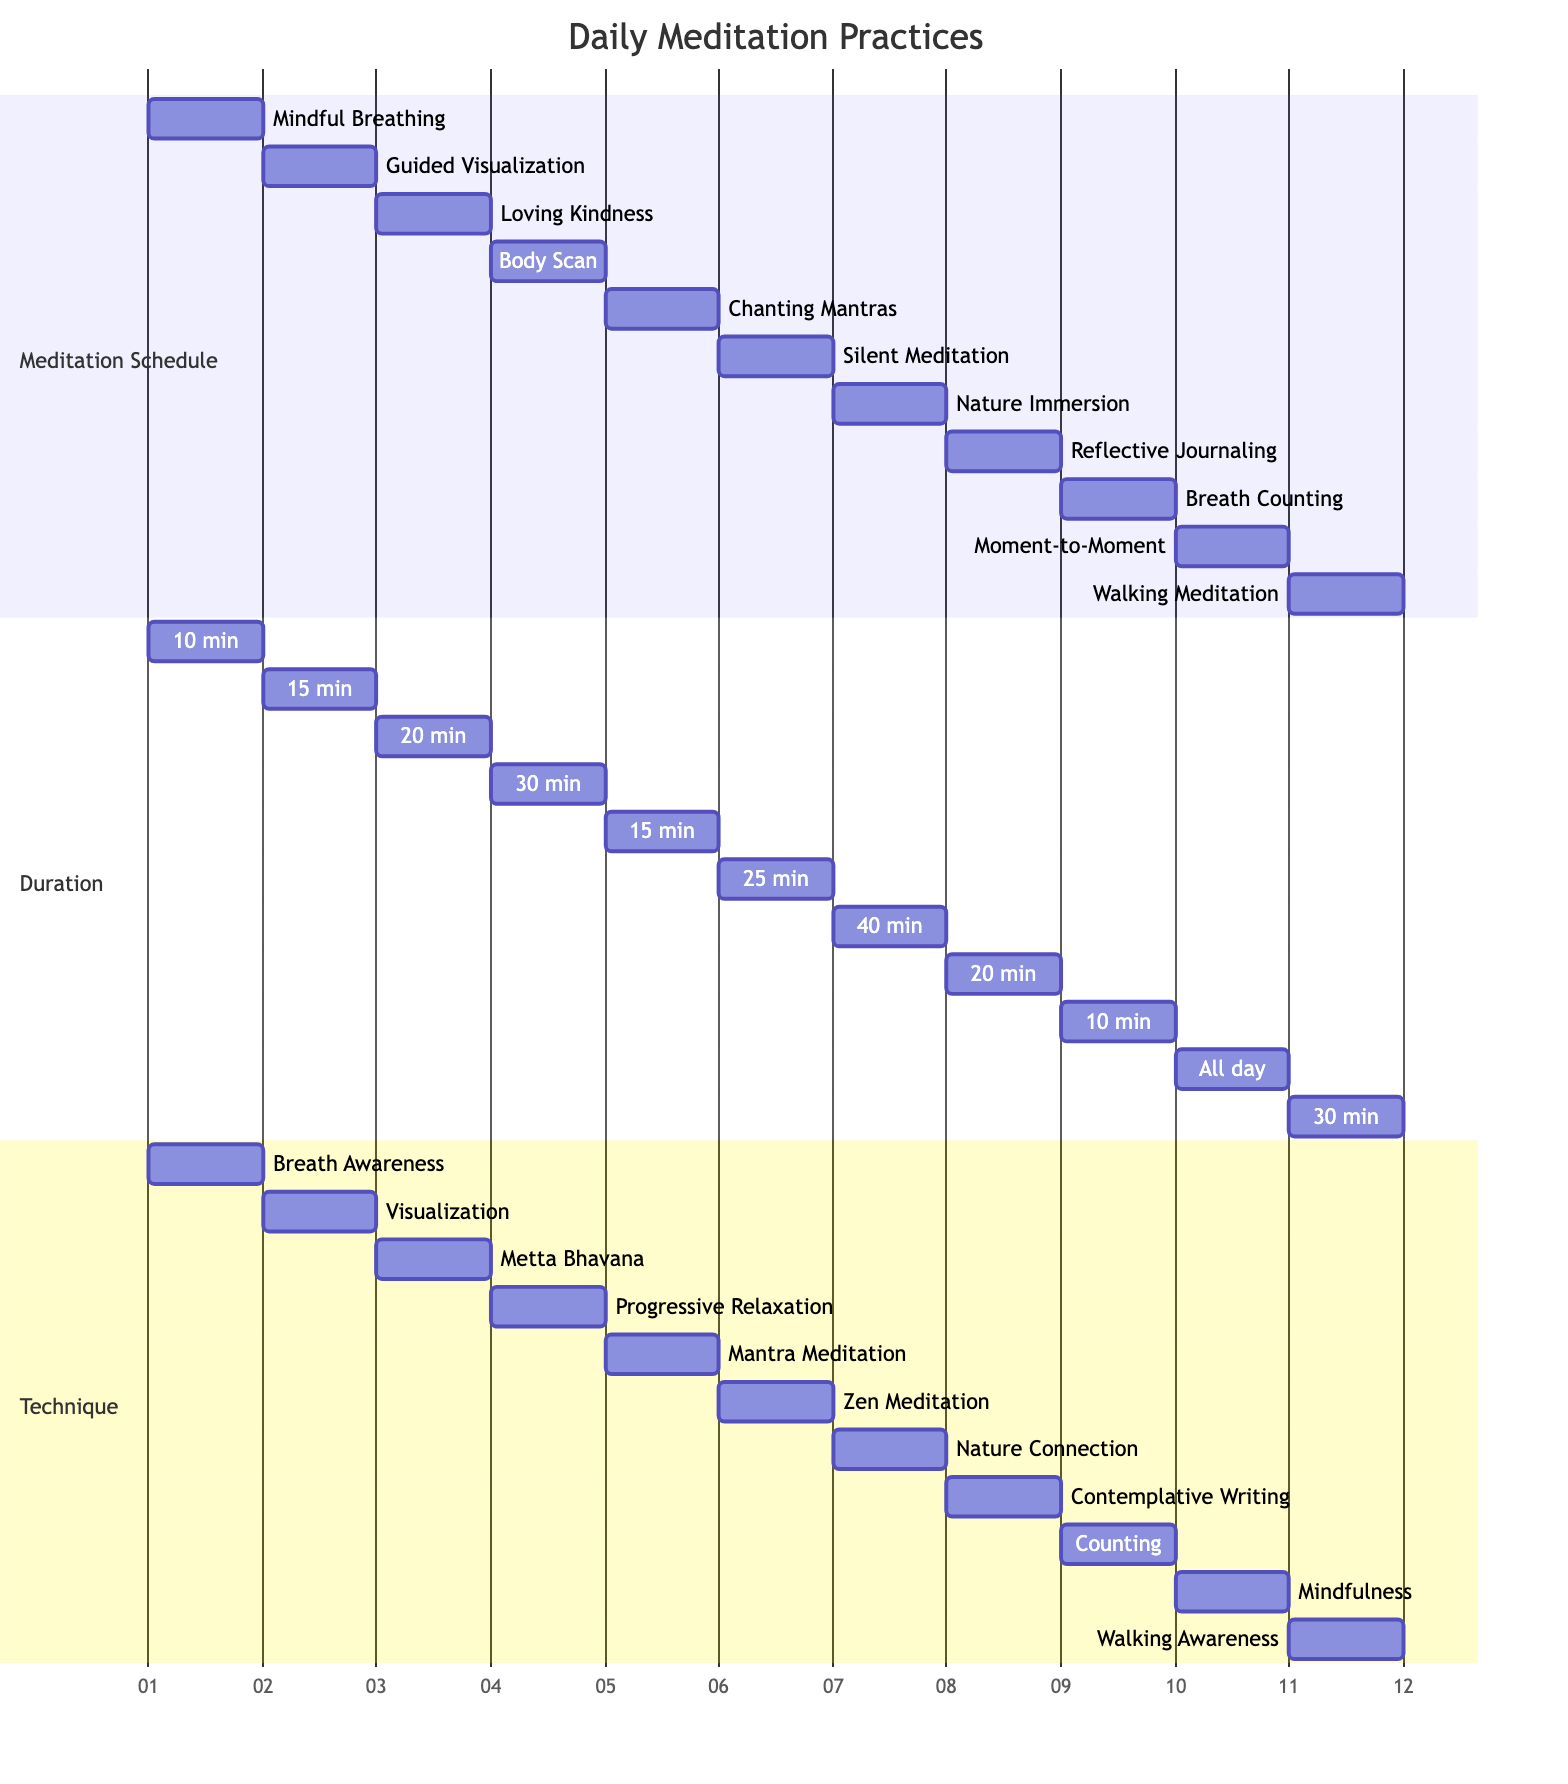What meditation technique is practiced on Day 1? The diagram indicates that on Day 1, the meditation practice is "Mindful Breathing," which focuses on present moment awareness through breath awareness.
Answer: Mindful Breathing How long is the Silent Meditation session? According to the diagram, the duration for Silent Meditation is specified as 25 minutes, which is noted under the duration section for Day 6.
Answer: 25 minutes On which day is Nature Immersion scheduled? By referring to the diagram, Nature Immersion can be found listed on Day 7, thus indicating when this specific practice is scheduled.
Answer: Day 7 What is the total number of meditation practices shown in the diagram? To find the total number of practices, count the number of entries under the Meditation Schedule section, which totals to 11 different meditation practices displayed in the diagram.
Answer: 11 Which meditation practice requires the longest duration? Upon examining the durations in the Duration section, the practice that takes the longest time is "Nature Immersion," which is set for 40 minutes, as listed on Day 7 in the schedule.
Answer: 40 minutes What is the technique associated with Loving Kindness Meditation? The diagram denotes that the Loving Kindness Meditation on Day 3 employs the technique known as Metta Bhavana, referring to its specific practice type.
Answer: Metta Bhavana Which meditation practice happens throughout the day? As per the diagram, "Moment-to-Moment Awareness" is indicated to be practiced "Throughout the day," suggesting its continuous application rather than a set duration.
Answer: Throughout the day How many minutes does Breath Counting meditation last? In the diagram, it shows that Breath Counting has a designated duration of 10 minutes, which can be directly seen under the respective practice entry for Day 9.
Answer: 10 minutes 